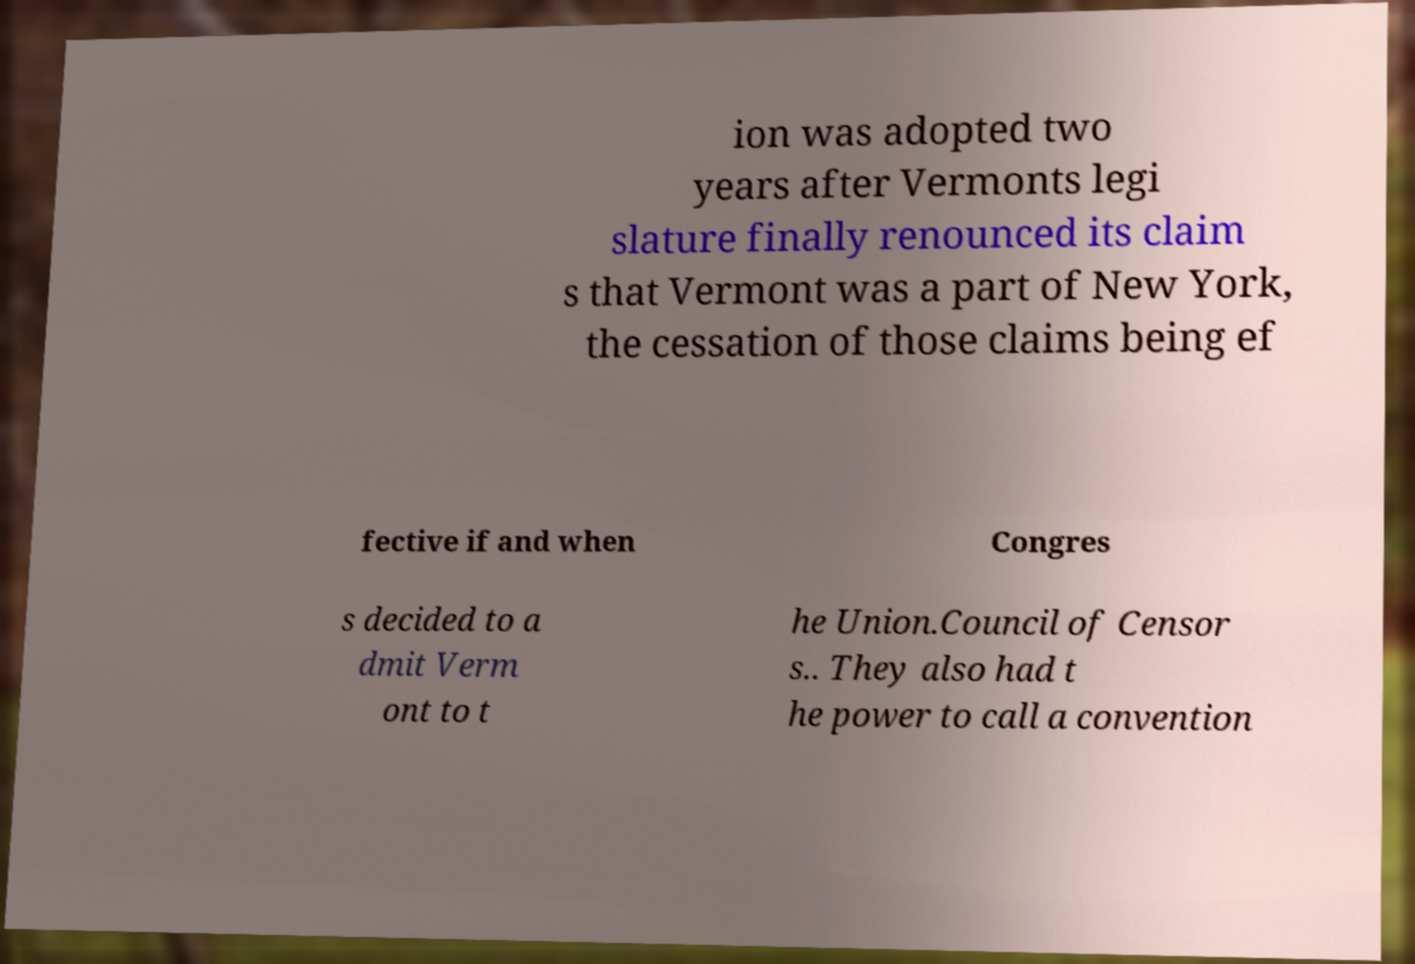Could you assist in decoding the text presented in this image and type it out clearly? ion was adopted two years after Vermonts legi slature finally renounced its claim s that Vermont was a part of New York, the cessation of those claims being ef fective if and when Congres s decided to a dmit Verm ont to t he Union.Council of Censor s.. They also had t he power to call a convention 